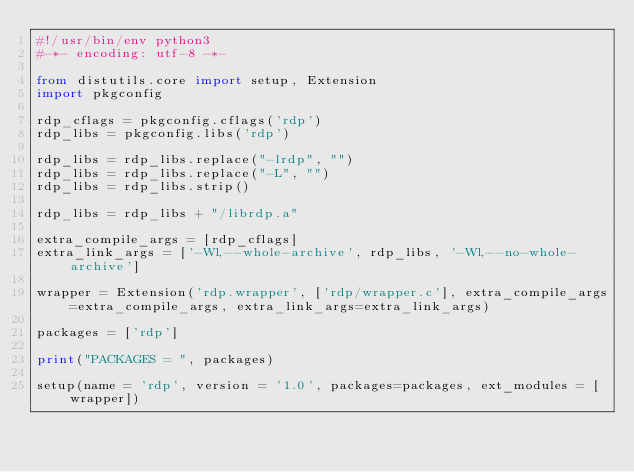<code> <loc_0><loc_0><loc_500><loc_500><_Python_>#!/usr/bin/env python3
#-*- encoding: utf-8 -*-

from distutils.core import setup, Extension
import pkgconfig

rdp_cflags = pkgconfig.cflags('rdp')
rdp_libs = pkgconfig.libs('rdp')

rdp_libs = rdp_libs.replace("-lrdp", "")
rdp_libs = rdp_libs.replace("-L", "")
rdp_libs = rdp_libs.strip()

rdp_libs = rdp_libs + "/librdp.a"

extra_compile_args = [rdp_cflags]
extra_link_args = ['-Wl,--whole-archive', rdp_libs, '-Wl,--no-whole-archive']

wrapper = Extension('rdp.wrapper', ['rdp/wrapper.c'], extra_compile_args=extra_compile_args, extra_link_args=extra_link_args)

packages = ['rdp']

print("PACKAGES = ", packages)

setup(name = 'rdp', version = '1.0', packages=packages, ext_modules = [wrapper])
</code> 